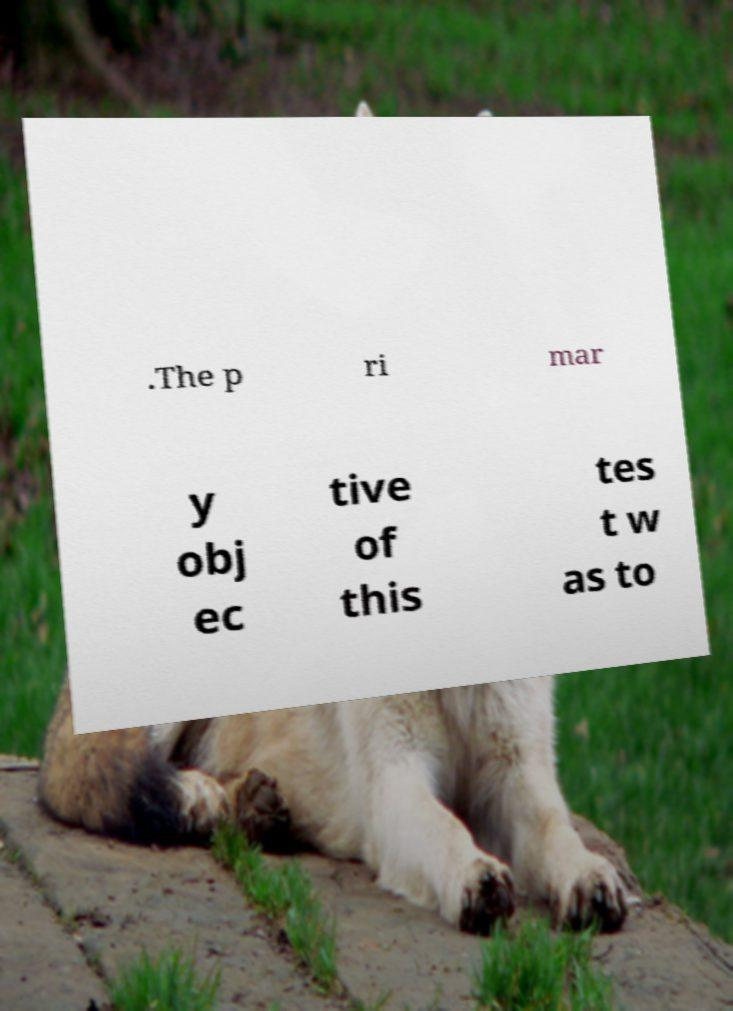For documentation purposes, I need the text within this image transcribed. Could you provide that? .The p ri mar y obj ec tive of this tes t w as to 